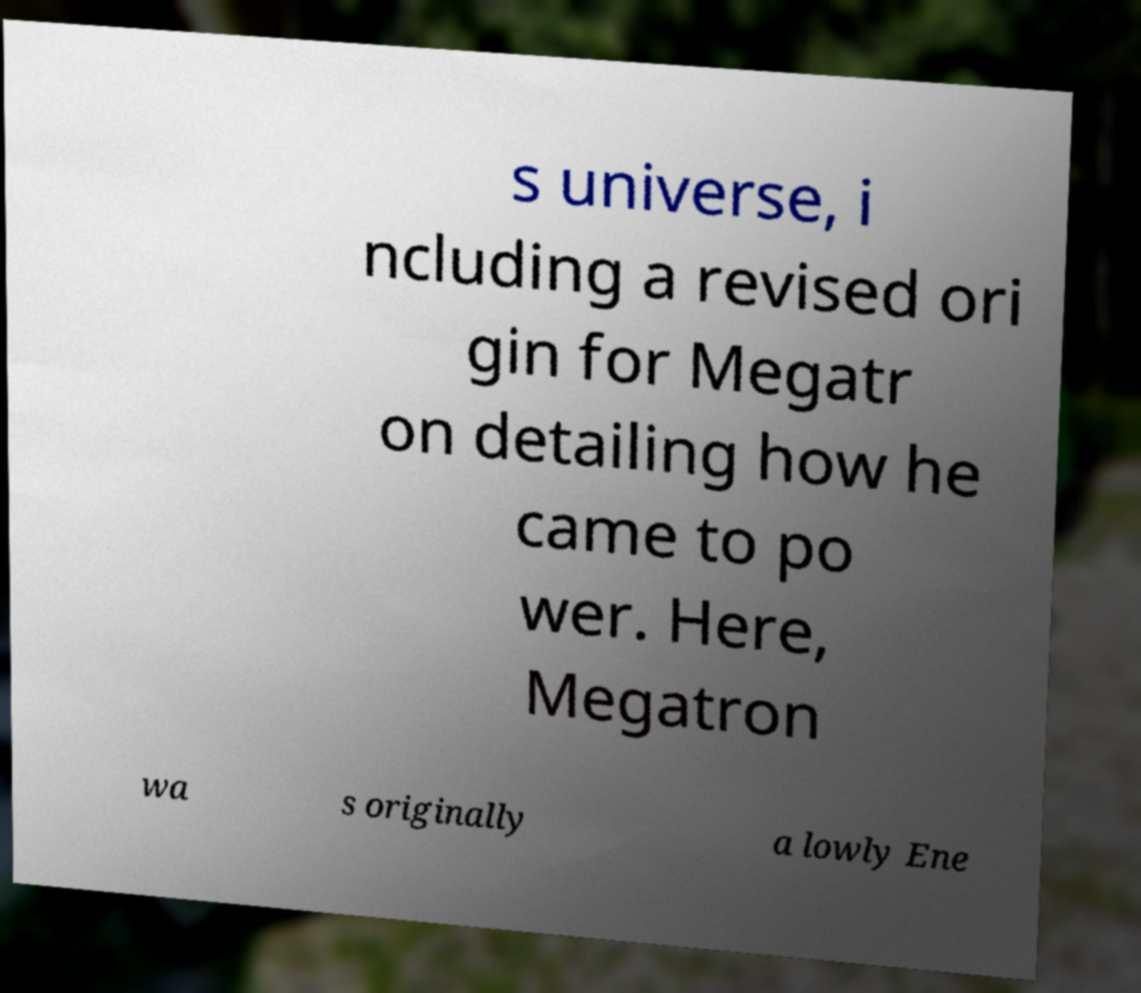There's text embedded in this image that I need extracted. Can you transcribe it verbatim? s universe, i ncluding a revised ori gin for Megatr on detailing how he came to po wer. Here, Megatron wa s originally a lowly Ene 